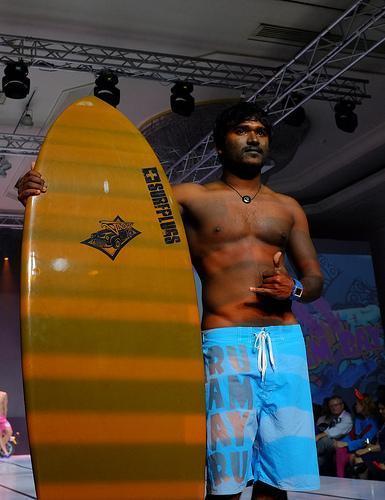How many surfboards are there?
Give a very brief answer. 1. How many yellow surfboards are there?
Give a very brief answer. 1. 